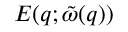<formula> <loc_0><loc_0><loc_500><loc_500>E ( q ; \tilde { \omega } ( q ) )</formula> 